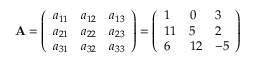<formula> <loc_0><loc_0><loc_500><loc_500>A = { \left ( \begin{array} { l l l } { a _ { 1 1 } } & { a _ { 1 2 } } & { a _ { 1 3 } } \\ { a _ { 2 1 } } & { a _ { 2 2 } } & { a _ { 2 3 } } \\ { a _ { 3 1 } } & { a _ { 3 2 } } & { a _ { 3 3 } } \end{array} \right ) } = { \left ( \begin{array} { l l l } { 1 } & { 0 } & { 3 } \\ { 1 1 } & { 5 } & { 2 } \\ { 6 } & { 1 2 } & { - 5 } \end{array} \right ) }</formula> 